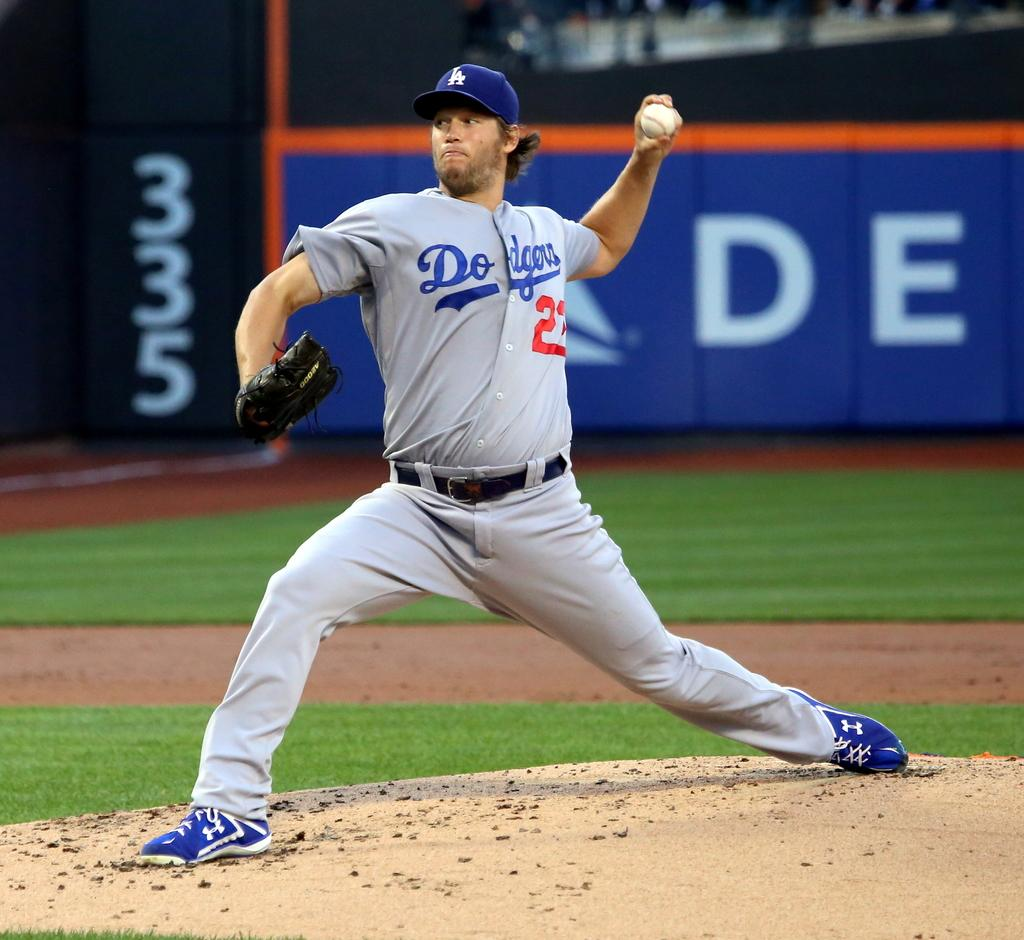<image>
Create a compact narrative representing the image presented. The baseball pitcher for the Dodgers is about to throw a baseball. 